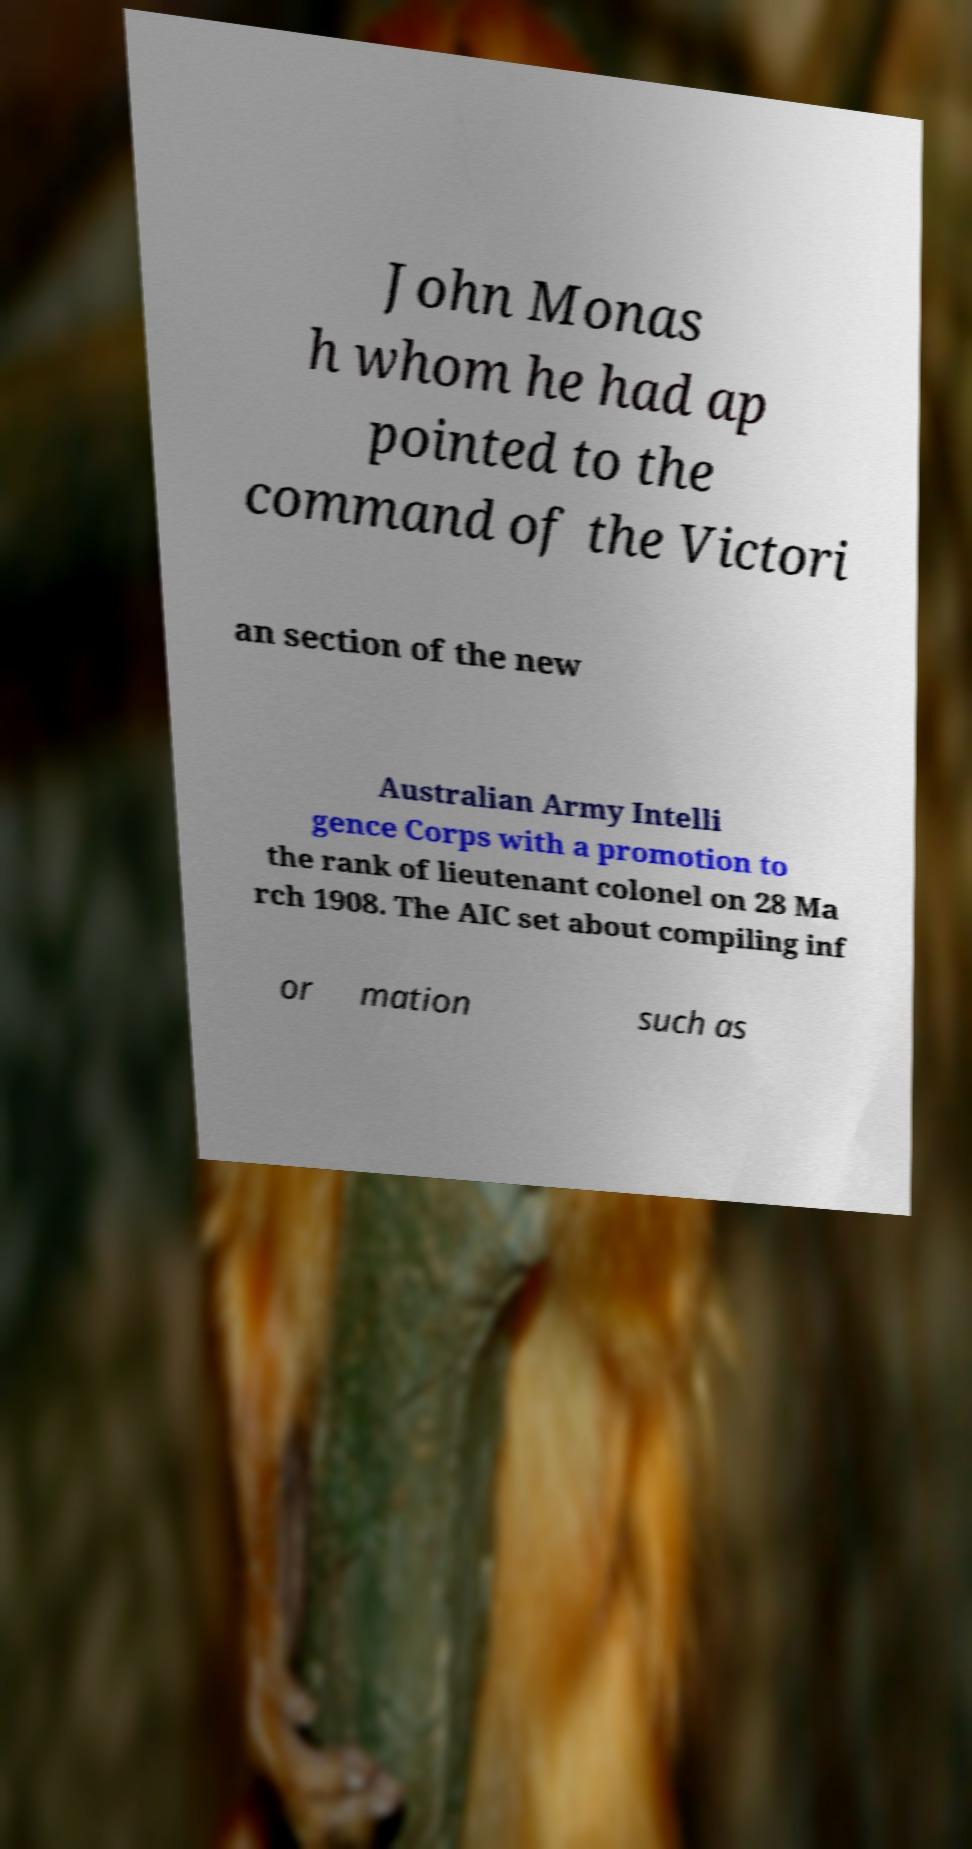Could you assist in decoding the text presented in this image and type it out clearly? John Monas h whom he had ap pointed to the command of the Victori an section of the new Australian Army Intelli gence Corps with a promotion to the rank of lieutenant colonel on 28 Ma rch 1908. The AIC set about compiling inf or mation such as 